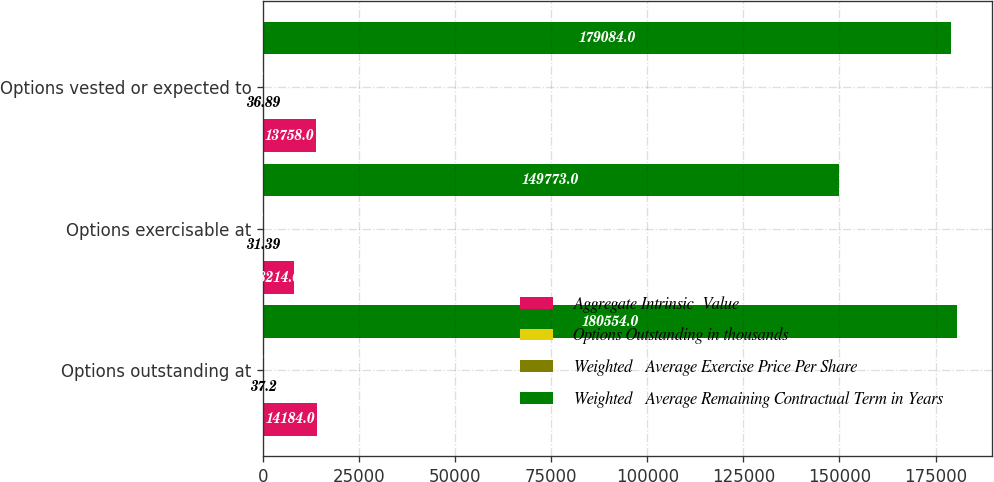<chart> <loc_0><loc_0><loc_500><loc_500><stacked_bar_chart><ecel><fcel>Options outstanding at<fcel>Options exercisable at<fcel>Options vested or expected to<nl><fcel>Aggregate Intrinsic  Value<fcel>14184<fcel>8214<fcel>13758<nl><fcel>Options Outstanding in thousands<fcel>37.2<fcel>31.39<fcel>36.89<nl><fcel>Weighted   Average Exercise Price Per Share<fcel>5.8<fcel>4.1<fcel>5.7<nl><fcel>Weighted   Average Remaining Contractual Term in Years<fcel>180554<fcel>149773<fcel>179084<nl></chart> 